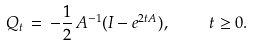Convert formula to latex. <formula><loc_0><loc_0><loc_500><loc_500>Q _ { t } \, = \, - \frac { 1 } { 2 } \, A ^ { - 1 } ( I - e ^ { 2 t A } ) , \, \quad t \geq 0 .</formula> 